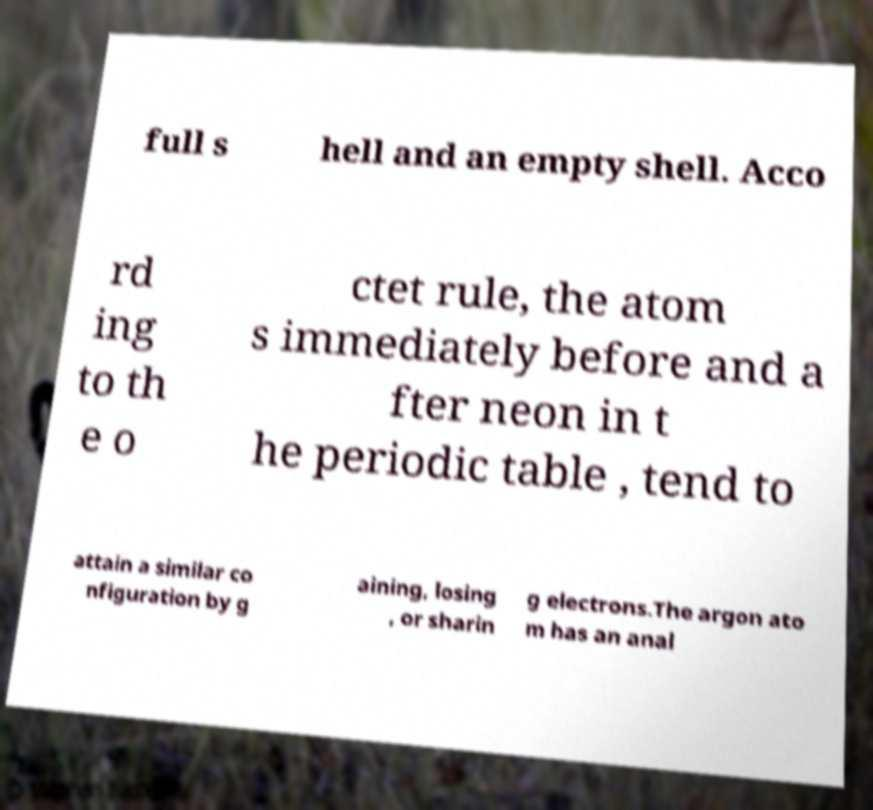Can you read and provide the text displayed in the image?This photo seems to have some interesting text. Can you extract and type it out for me? full s hell and an empty shell. Acco rd ing to th e o ctet rule, the atom s immediately before and a fter neon in t he periodic table , tend to attain a similar co nfiguration by g aining, losing , or sharin g electrons.The argon ato m has an anal 